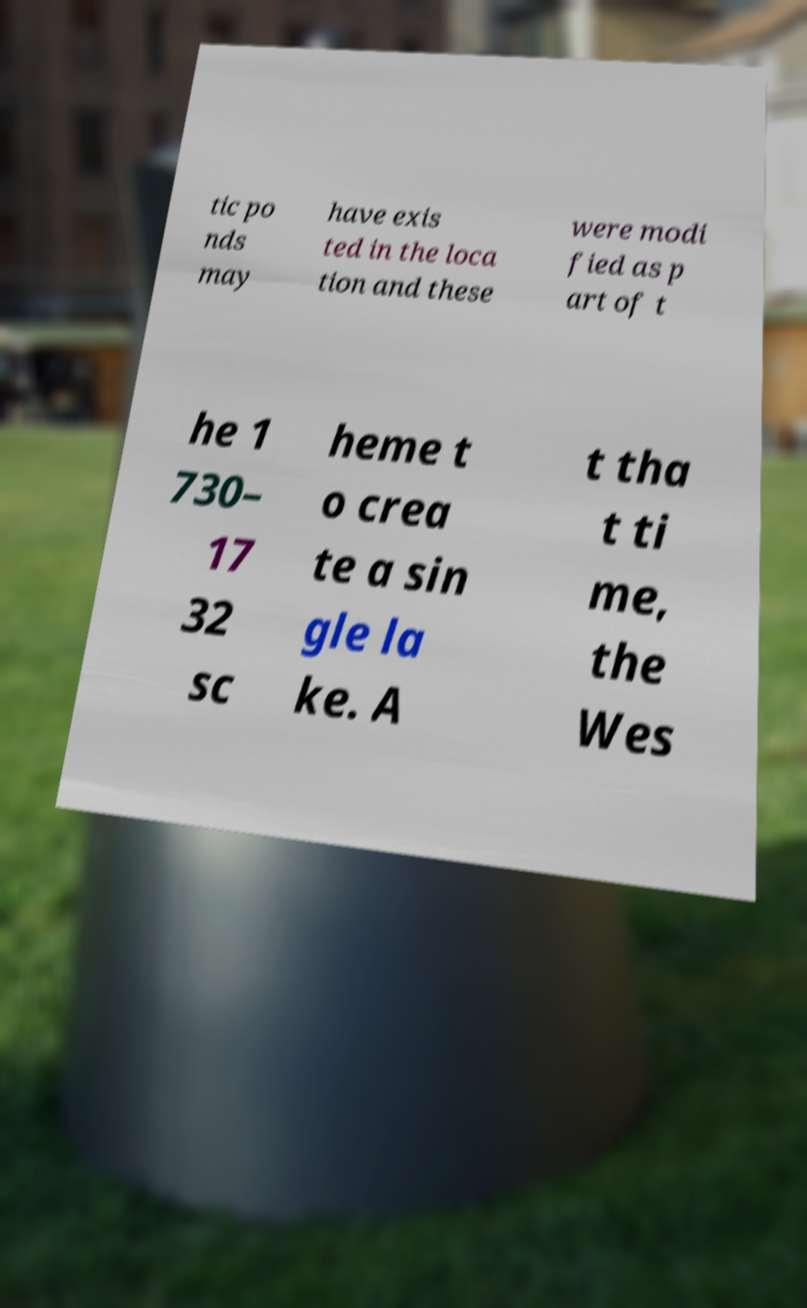Can you read and provide the text displayed in the image?This photo seems to have some interesting text. Can you extract and type it out for me? tic po nds may have exis ted in the loca tion and these were modi fied as p art of t he 1 730– 17 32 sc heme t o crea te a sin gle la ke. A t tha t ti me, the Wes 